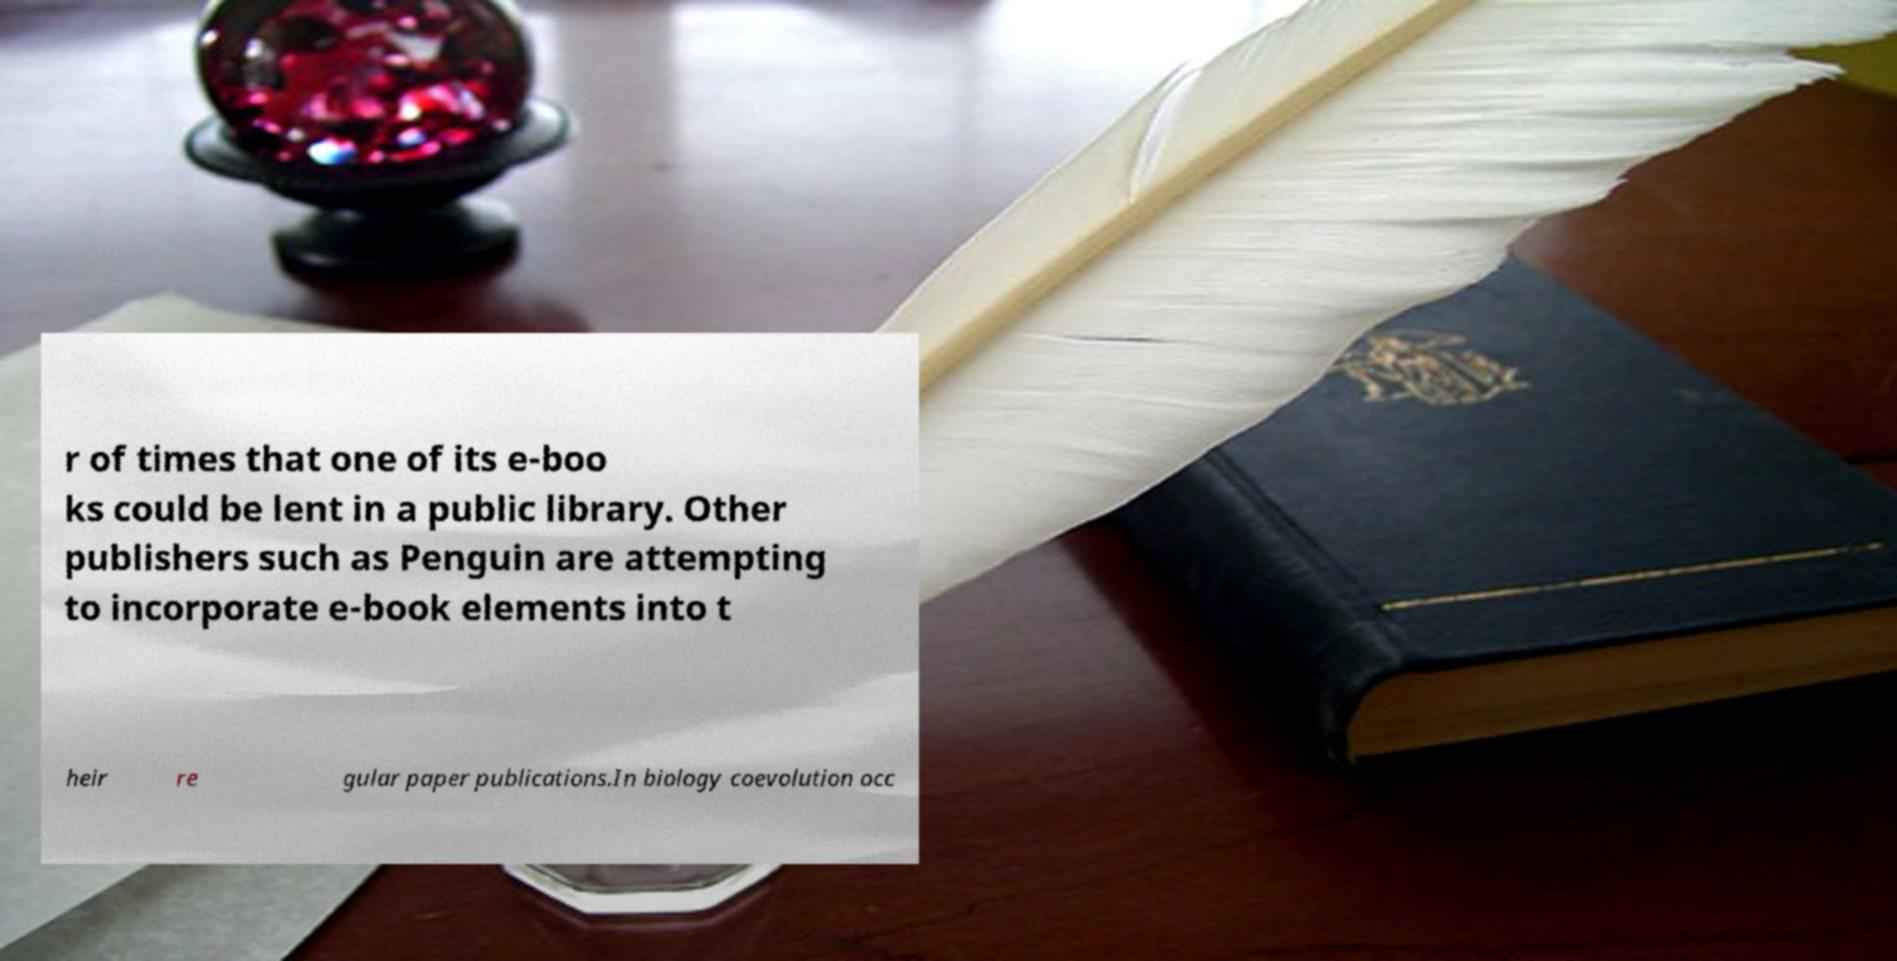For documentation purposes, I need the text within this image transcribed. Could you provide that? r of times that one of its e-boo ks could be lent in a public library. Other publishers such as Penguin are attempting to incorporate e-book elements into t heir re gular paper publications.In biology coevolution occ 